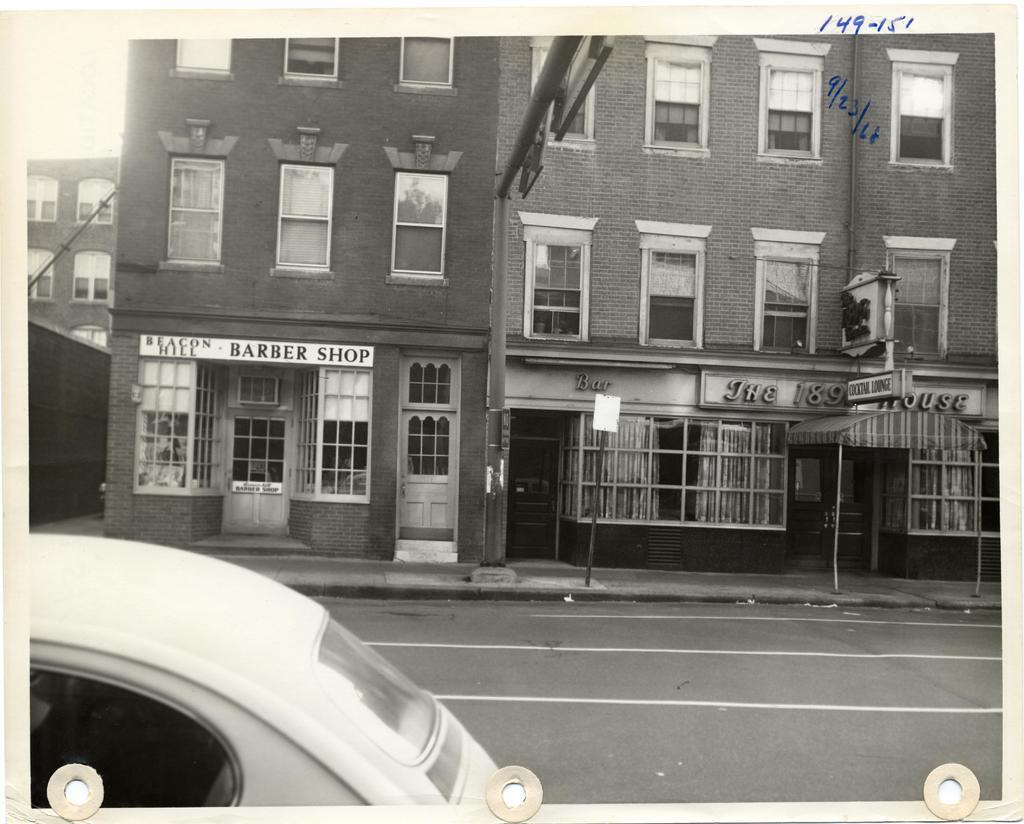What is the main subject of the image? The main subject of the image is a photo. What can be seen in the photo? The photo contains a road, a vehicle, a footpath, poles, name boards, buildings with windows, and some objects. Can you describe the buildings in the photo? The buildings in the photo have windows. What type of destruction can be seen in the photo? There is no destruction present in the photo; it contains a road, a vehicle, a footpath, poles, name boards, buildings with windows, and some objects. Can you tell me what color the ball is in the photo? There is no ball present in the photo. 